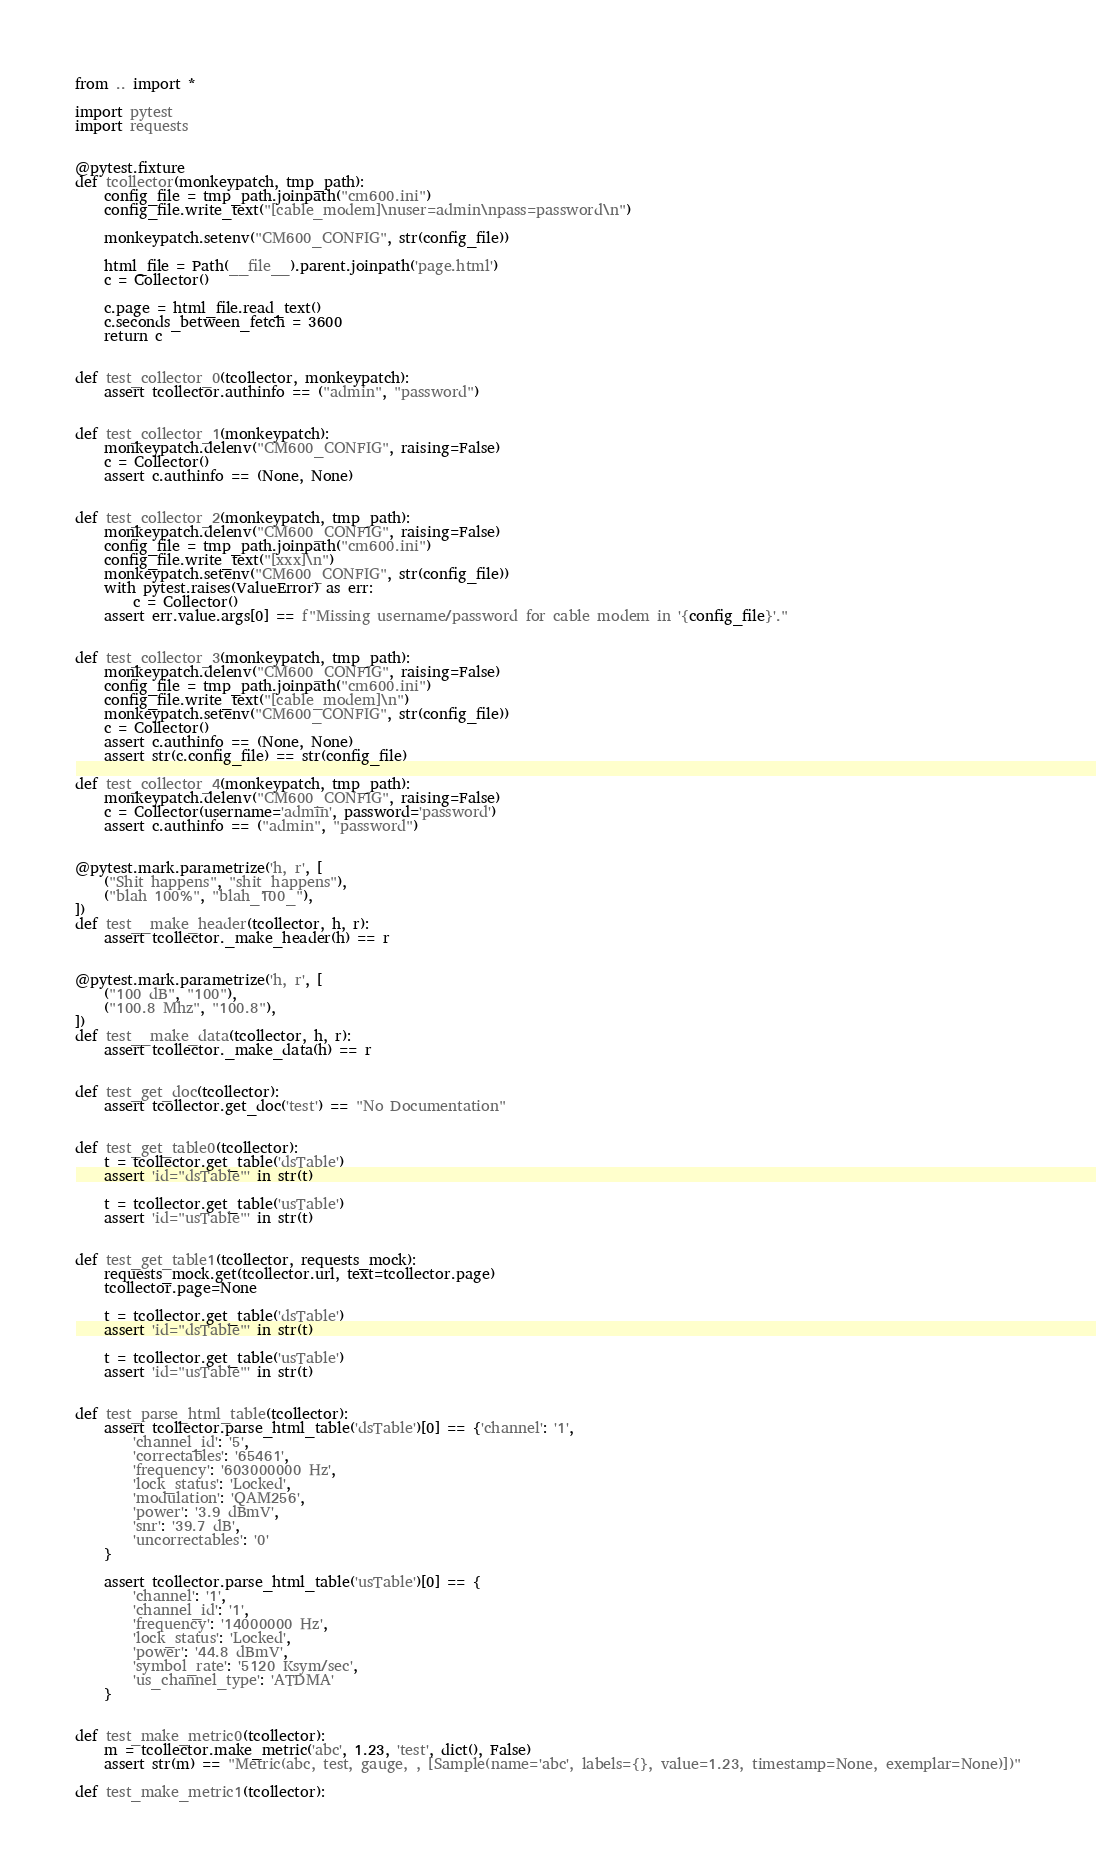<code> <loc_0><loc_0><loc_500><loc_500><_Python_>from .. import *

import pytest
import requests


@pytest.fixture
def tcollector(monkeypatch, tmp_path):
    config_file = tmp_path.joinpath("cm600.ini")
    config_file.write_text("[cable_modem]\nuser=admin\npass=password\n")

    monkeypatch.setenv("CM600_CONFIG", str(config_file))

    html_file = Path(__file__).parent.joinpath('page.html')
    c = Collector()

    c.page = html_file.read_text()
    c.seconds_between_fetch = 3600
    return c


def test_collector_0(tcollector, monkeypatch):
    assert tcollector.authinfo == ("admin", "password")


def test_collector_1(monkeypatch):
    monkeypatch.delenv("CM600_CONFIG", raising=False)
    c = Collector()
    assert c.authinfo == (None, None)


def test_collector_2(monkeypatch, tmp_path):
    monkeypatch.delenv("CM600_CONFIG", raising=False)
    config_file = tmp_path.joinpath("cm600.ini")
    config_file.write_text("[xxx]\n")
    monkeypatch.setenv("CM600_CONFIG", str(config_file))
    with pytest.raises(ValueError) as err:
        c = Collector()
    assert err.value.args[0] == f"Missing username/password for cable modem in '{config_file}'."


def test_collector_3(monkeypatch, tmp_path):
    monkeypatch.delenv("CM600_CONFIG", raising=False)
    config_file = tmp_path.joinpath("cm600.ini")
    config_file.write_text("[cable_modem]\n")
    monkeypatch.setenv("CM600_CONFIG", str(config_file))
    c = Collector()
    assert c.authinfo == (None, None)
    assert str(c.config_file) == str(config_file)

def test_collector_4(monkeypatch, tmp_path):
    monkeypatch.delenv("CM600_CONFIG", raising=False)
    c = Collector(username='admin', password='password')
    assert c.authinfo == ("admin", "password")


@pytest.mark.parametrize('h, r', [
    ("Shit happens", "shit_happens"),
    ("blah 100%", "blah_100_"),
])
def test__make_header(tcollector, h, r):
    assert tcollector._make_header(h) == r


@pytest.mark.parametrize('h, r', [
    ("100 dB", "100"),
    ("100.8 Mhz", "100.8"),
])
def test__make_data(tcollector, h, r):
    assert tcollector._make_data(h) == r


def test_get_doc(tcollector):
    assert tcollector.get_doc('test') == "No Documentation"


def test_get_table0(tcollector):
    t = tcollector.get_table('dsTable')
    assert 'id="dsTable"' in str(t)

    t = tcollector.get_table('usTable')
    assert 'id="usTable"' in str(t)


def test_get_table1(tcollector, requests_mock):
    requests_mock.get(tcollector.url, text=tcollector.page)
    tcollector.page=None

    t = tcollector.get_table('dsTable')
    assert 'id="dsTable"' in str(t)

    t = tcollector.get_table('usTable')
    assert 'id="usTable"' in str(t)


def test_parse_html_table(tcollector):
    assert tcollector.parse_html_table('dsTable')[0] == {'channel': '1',
        'channel_id': '5',
        'correctables': '65461',
        'frequency': '603000000 Hz',
        'lock_status': 'Locked',
        'modulation': 'QAM256',
        'power': '3.9 dBmV',
        'snr': '39.7 dB',
        'uncorrectables': '0'
    }

    assert tcollector.parse_html_table('usTable')[0] == {
        'channel': '1',
        'channel_id': '1',
        'frequency': '14000000 Hz',
        'lock_status': 'Locked',
        'power': '44.8 dBmV',
        'symbol_rate': '5120 Ksym/sec',
        'us_channel_type': 'ATDMA'
    }


def test_make_metric0(tcollector):
    m = tcollector.make_metric('abc', 1.23, 'test', dict(), False)
    assert str(m) == "Metric(abc, test, gauge, , [Sample(name='abc', labels={}, value=1.23, timestamp=None, exemplar=None)])"

def test_make_metric1(tcollector):</code> 